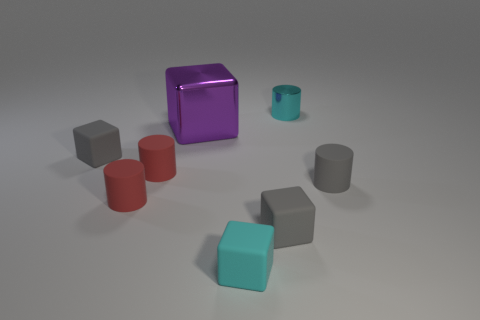Subtract all cyan blocks. How many blocks are left? 3 Subtract all yellow cylinders. How many gray cubes are left? 2 Subtract 1 cylinders. How many cylinders are left? 3 Subtract all cyan cylinders. How many cylinders are left? 3 Add 2 small red cylinders. How many objects exist? 10 Subtract all red cylinders. Subtract all green spheres. How many cylinders are left? 2 Subtract 0 purple cylinders. How many objects are left? 8 Subtract all cyan objects. Subtract all big cyan rubber cylinders. How many objects are left? 6 Add 6 tiny red matte cylinders. How many tiny red matte cylinders are left? 8 Add 5 small cyan matte spheres. How many small cyan matte spheres exist? 5 